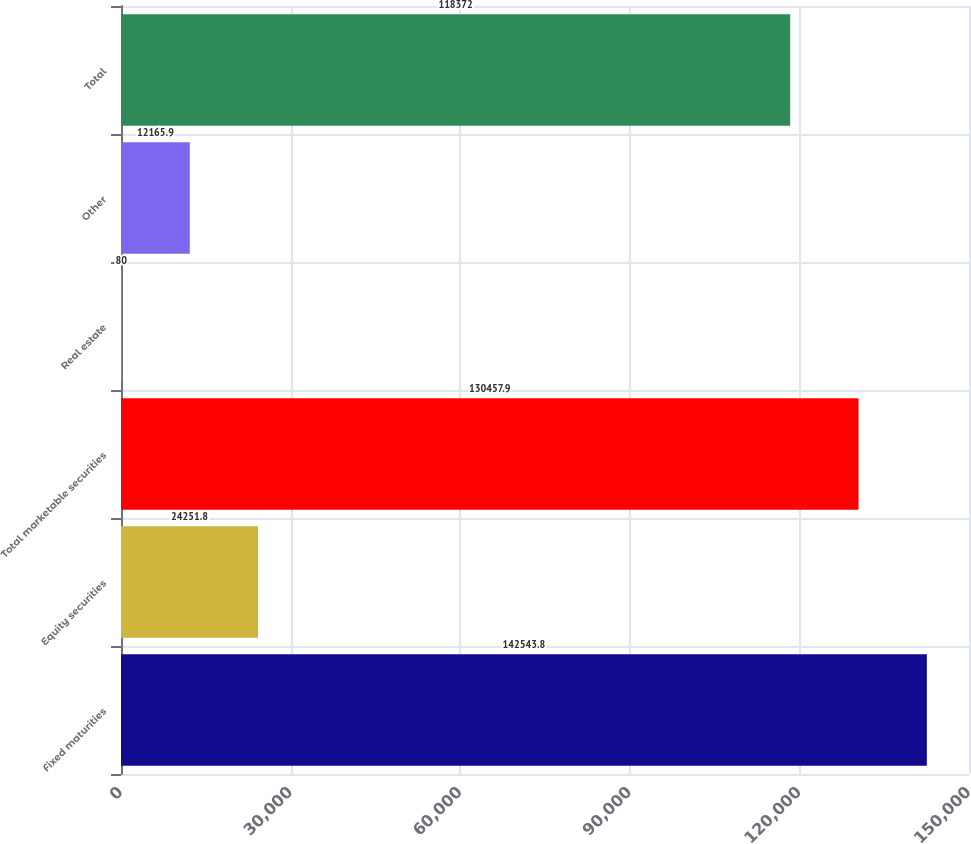<chart> <loc_0><loc_0><loc_500><loc_500><bar_chart><fcel>Fixed maturities<fcel>Equity securities<fcel>Total marketable securities<fcel>Real estate<fcel>Other<fcel>Total<nl><fcel>142544<fcel>24251.8<fcel>130458<fcel>80<fcel>12165.9<fcel>118372<nl></chart> 